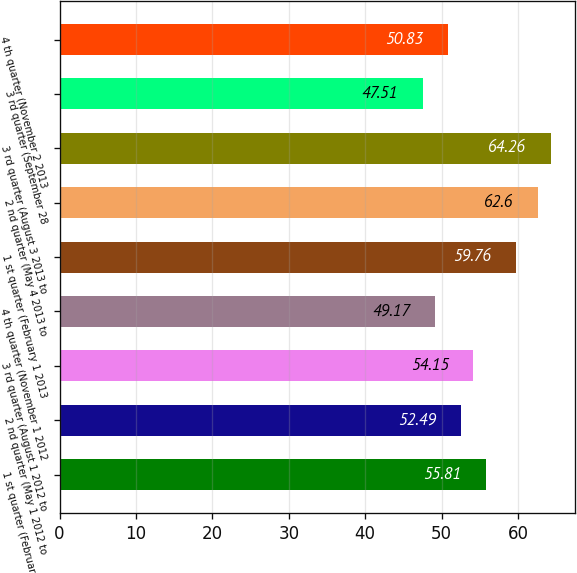Convert chart to OTSL. <chart><loc_0><loc_0><loc_500><loc_500><bar_chart><fcel>1 st quarter (February 1 2012<fcel>2 nd quarter (May 1 2012 to<fcel>3 rd quarter (August 1 2012 to<fcel>4 th quarter (November 1 2012<fcel>1 st quarter (February 1 2013<fcel>2 nd quarter (May 4 2013 to<fcel>3 rd quarter (August 3 2013 to<fcel>3 rd quarter (September 28<fcel>4 th quarter (November 2 2013<nl><fcel>55.81<fcel>52.49<fcel>54.15<fcel>49.17<fcel>59.76<fcel>62.6<fcel>64.26<fcel>47.51<fcel>50.83<nl></chart> 